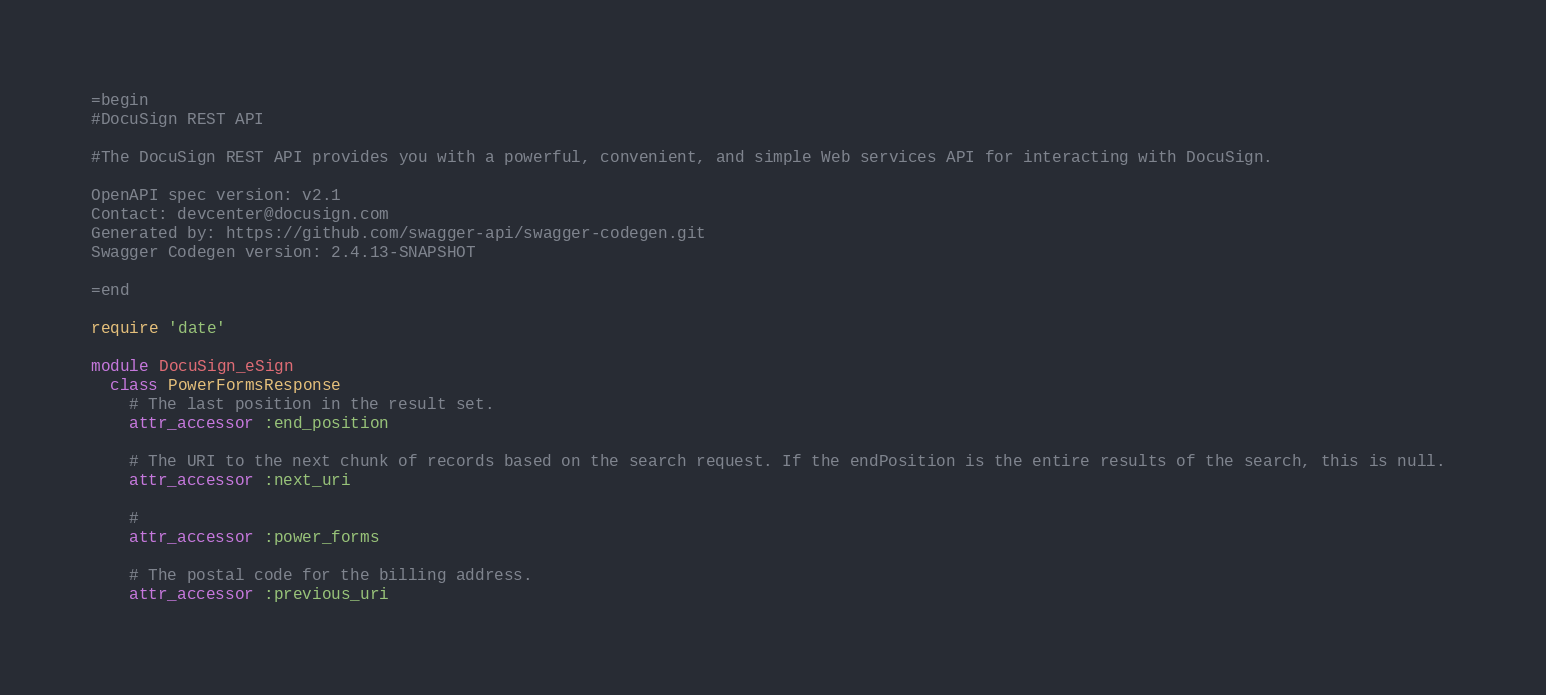<code> <loc_0><loc_0><loc_500><loc_500><_Ruby_>=begin
#DocuSign REST API

#The DocuSign REST API provides you with a powerful, convenient, and simple Web services API for interacting with DocuSign.

OpenAPI spec version: v2.1
Contact: devcenter@docusign.com
Generated by: https://github.com/swagger-api/swagger-codegen.git
Swagger Codegen version: 2.4.13-SNAPSHOT

=end

require 'date'

module DocuSign_eSign
  class PowerFormsResponse
    # The last position in the result set. 
    attr_accessor :end_position

    # The URI to the next chunk of records based on the search request. If the endPosition is the entire results of the search, this is null. 
    attr_accessor :next_uri

    # 
    attr_accessor :power_forms

    # The postal code for the billing address.
    attr_accessor :previous_uri
</code> 